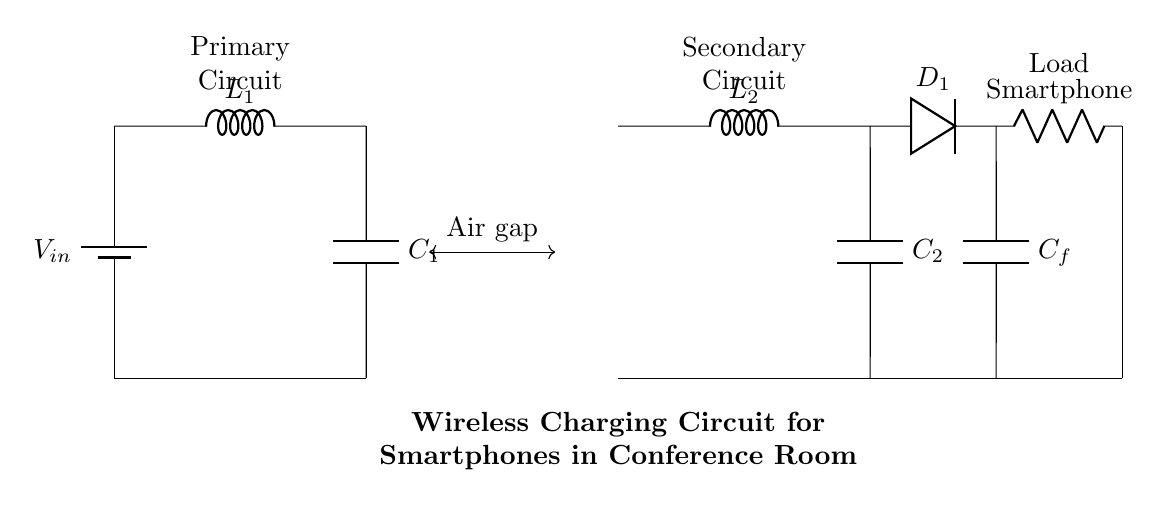What components are in the primary circuit? The primary circuit consists of a battery, an inductor labeled L1, and a capacitor labeled C1. The battery provides the input voltage, while the inductor and capacitor are used to form a resonant circuit.
Answer: Battery, L1, C1 What is the role of the diode in this circuit? The diode, labeled D1, serves as a rectifier to convert the alternating current (AC) generated by the secondary coil L2 into direct current (DC) that can be used by the smartphone load.
Answer: Rectifier What is the air gap between the coils? The air gap is represented by a double-sided arrow connecting the primary coil and secondary coil. It indicates the physical distance that separates the two coils, which is necessary for wireless energy transfer.
Answer: Air gap How many capacitors are present in the circuit? There are three capacitors: C1 in the primary circuit, C2 in the secondary circuit, and Cf, which is connected to the diode D1 for smoothing the rectified output voltage.
Answer: Three What is the load represented in the circuit? The load in this circuit is the smartphone, which is connected to the output of the rectifier. It draws power wirelessly through the secondary coil and utilizes it for charging.
Answer: Smartphone What type of circuit is represented here? This circuit represents a wireless charging circuit employing inductive coupling between the primary and secondary coils for transferring energy without direct electrical connections.
Answer: Wireless charging circuit 